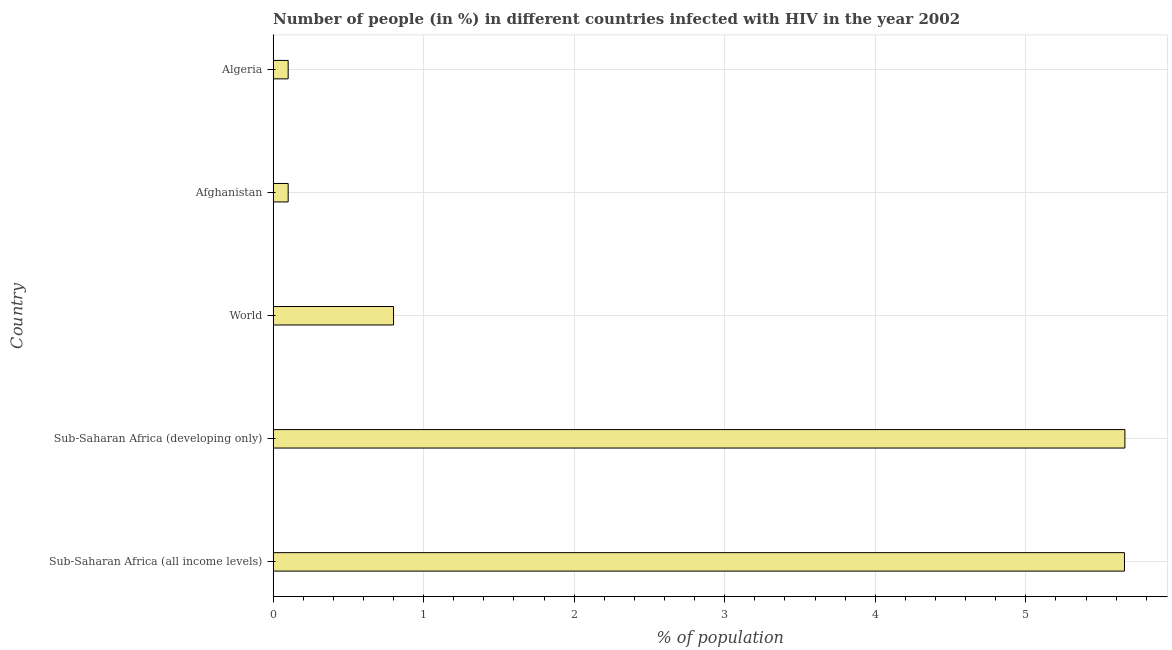Does the graph contain any zero values?
Your response must be concise. No. Does the graph contain grids?
Offer a very short reply. Yes. What is the title of the graph?
Offer a terse response. Number of people (in %) in different countries infected with HIV in the year 2002. What is the label or title of the X-axis?
Provide a succinct answer. % of population. Across all countries, what is the maximum number of people infected with hiv?
Ensure brevity in your answer.  5.66. In which country was the number of people infected with hiv maximum?
Offer a very short reply. Sub-Saharan Africa (developing only). In which country was the number of people infected with hiv minimum?
Give a very brief answer. Afghanistan. What is the sum of the number of people infected with hiv?
Provide a short and direct response. 12.31. What is the difference between the number of people infected with hiv in Afghanistan and Sub-Saharan Africa (all income levels)?
Provide a succinct answer. -5.56. What is the average number of people infected with hiv per country?
Provide a succinct answer. 2.46. In how many countries, is the number of people infected with hiv greater than 2.6 %?
Provide a short and direct response. 2. What is the ratio of the number of people infected with hiv in Afghanistan to that in Algeria?
Your response must be concise. 1. Is the number of people infected with hiv in Afghanistan less than that in Sub-Saharan Africa (all income levels)?
Keep it short and to the point. Yes. Is the difference between the number of people infected with hiv in Afghanistan and World greater than the difference between any two countries?
Make the answer very short. No. What is the difference between the highest and the second highest number of people infected with hiv?
Ensure brevity in your answer.  0. What is the difference between the highest and the lowest number of people infected with hiv?
Offer a terse response. 5.56. In how many countries, is the number of people infected with hiv greater than the average number of people infected with hiv taken over all countries?
Offer a very short reply. 2. How many bars are there?
Your answer should be compact. 5. Are all the bars in the graph horizontal?
Your response must be concise. Yes. How many countries are there in the graph?
Your answer should be very brief. 5. What is the difference between two consecutive major ticks on the X-axis?
Keep it short and to the point. 1. What is the % of population of Sub-Saharan Africa (all income levels)?
Make the answer very short. 5.66. What is the % of population of Sub-Saharan Africa (developing only)?
Your response must be concise. 5.66. What is the % of population of World?
Keep it short and to the point. 0.8. What is the % of population of Afghanistan?
Ensure brevity in your answer.  0.1. What is the difference between the % of population in Sub-Saharan Africa (all income levels) and Sub-Saharan Africa (developing only)?
Your answer should be very brief. -0. What is the difference between the % of population in Sub-Saharan Africa (all income levels) and World?
Your answer should be compact. 4.86. What is the difference between the % of population in Sub-Saharan Africa (all income levels) and Afghanistan?
Your response must be concise. 5.56. What is the difference between the % of population in Sub-Saharan Africa (all income levels) and Algeria?
Your response must be concise. 5.56. What is the difference between the % of population in Sub-Saharan Africa (developing only) and World?
Provide a succinct answer. 4.86. What is the difference between the % of population in Sub-Saharan Africa (developing only) and Afghanistan?
Provide a short and direct response. 5.56. What is the difference between the % of population in Sub-Saharan Africa (developing only) and Algeria?
Give a very brief answer. 5.56. What is the difference between the % of population in Afghanistan and Algeria?
Provide a succinct answer. 0. What is the ratio of the % of population in Sub-Saharan Africa (all income levels) to that in Sub-Saharan Africa (developing only)?
Offer a terse response. 1. What is the ratio of the % of population in Sub-Saharan Africa (all income levels) to that in World?
Make the answer very short. 7.07. What is the ratio of the % of population in Sub-Saharan Africa (all income levels) to that in Afghanistan?
Offer a terse response. 56.56. What is the ratio of the % of population in Sub-Saharan Africa (all income levels) to that in Algeria?
Your answer should be very brief. 56.56. What is the ratio of the % of population in Sub-Saharan Africa (developing only) to that in World?
Your response must be concise. 7.07. What is the ratio of the % of population in Sub-Saharan Africa (developing only) to that in Afghanistan?
Give a very brief answer. 56.58. What is the ratio of the % of population in Sub-Saharan Africa (developing only) to that in Algeria?
Your response must be concise. 56.58. What is the ratio of the % of population in Afghanistan to that in Algeria?
Offer a very short reply. 1. 